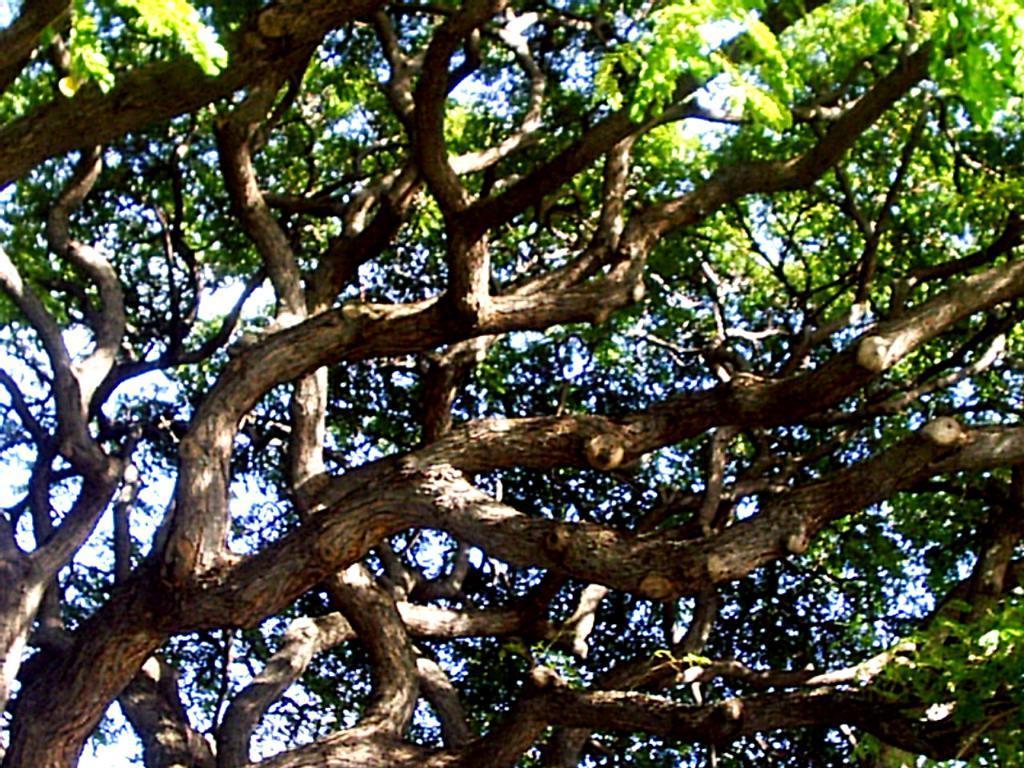Describe this image in one or two sentences. This is a picture of a tree with big branches. 